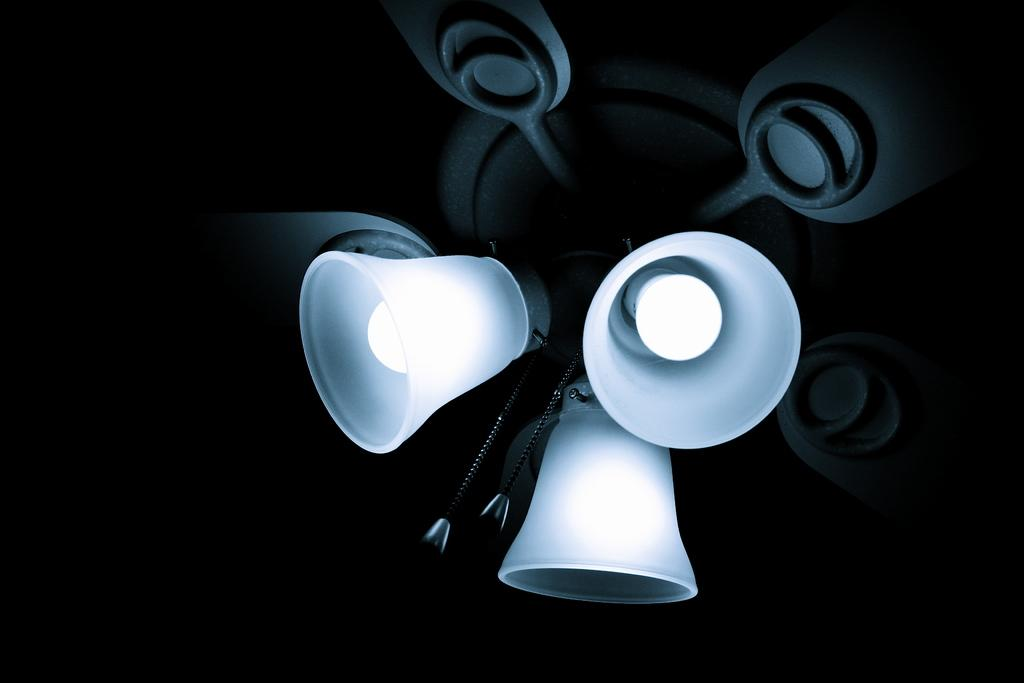What animals are depicted on the ceiling in the image? There are lambs on the ceiling in the image. What can be said about the overall lighting or color of the background in the image? The background of the image is dark. What type of can is visible on the ceiling with the lambs in the image? There is no can present in the image; it only features lambs on the ceiling. What direction is the zephyr blowing in the image? There is no mention of a zephyr or any wind in the image; it only shows lambs on the ceiling and a dark background. 